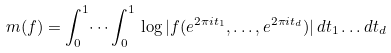<formula> <loc_0><loc_0><loc_500><loc_500>\ m ( f ) = \int _ { 0 } ^ { 1 } \dots \int _ { 0 } ^ { 1 } \, \log | f ( e ^ { 2 \pi i t _ { 1 } } , \dots , e ^ { 2 \pi i t _ { d } } ) | \, d t _ { 1 } \dots d t _ { d }</formula> 